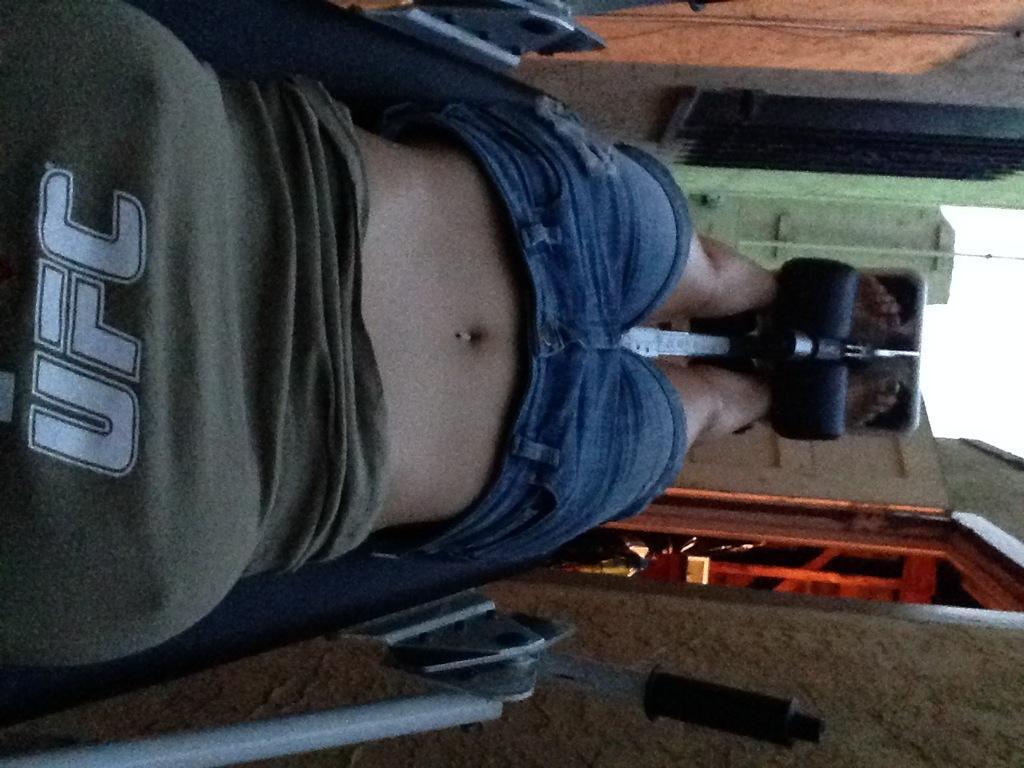Describe this image in one or two sentences. In the foreground of this image, there is a woman lying on the gym equipment. In the background, there is a wall, an entrance, door, a pole to the building and the sky. 